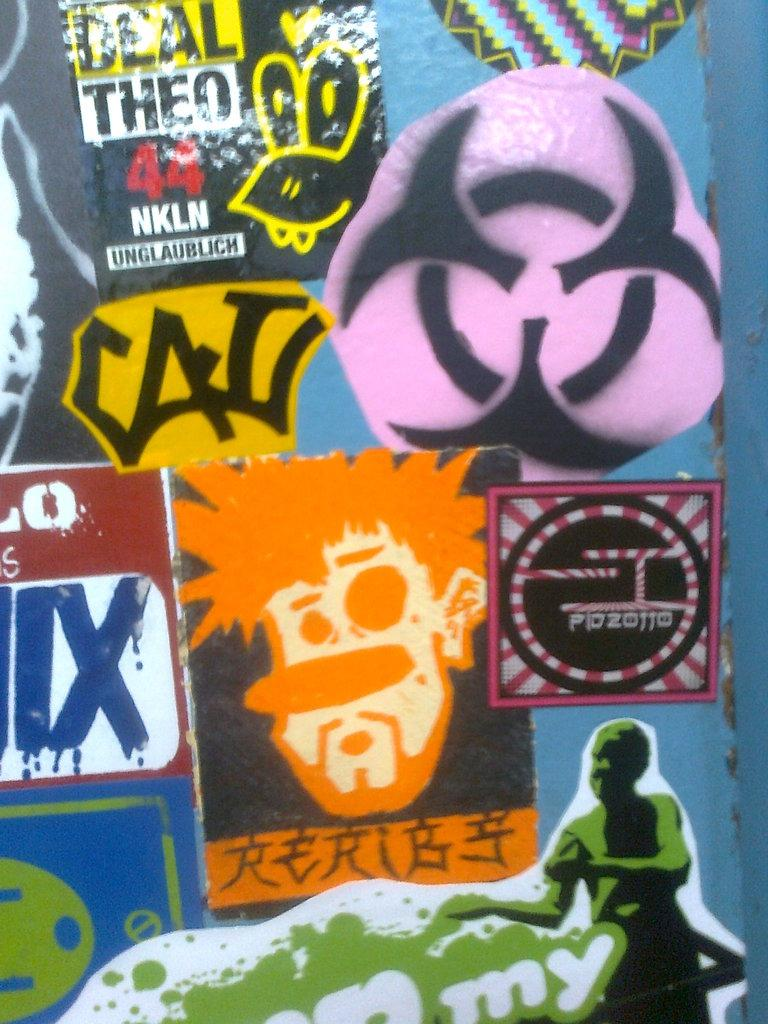<image>
Relay a brief, clear account of the picture shown. Closeup of various graffiti stickers including one reading CAL 